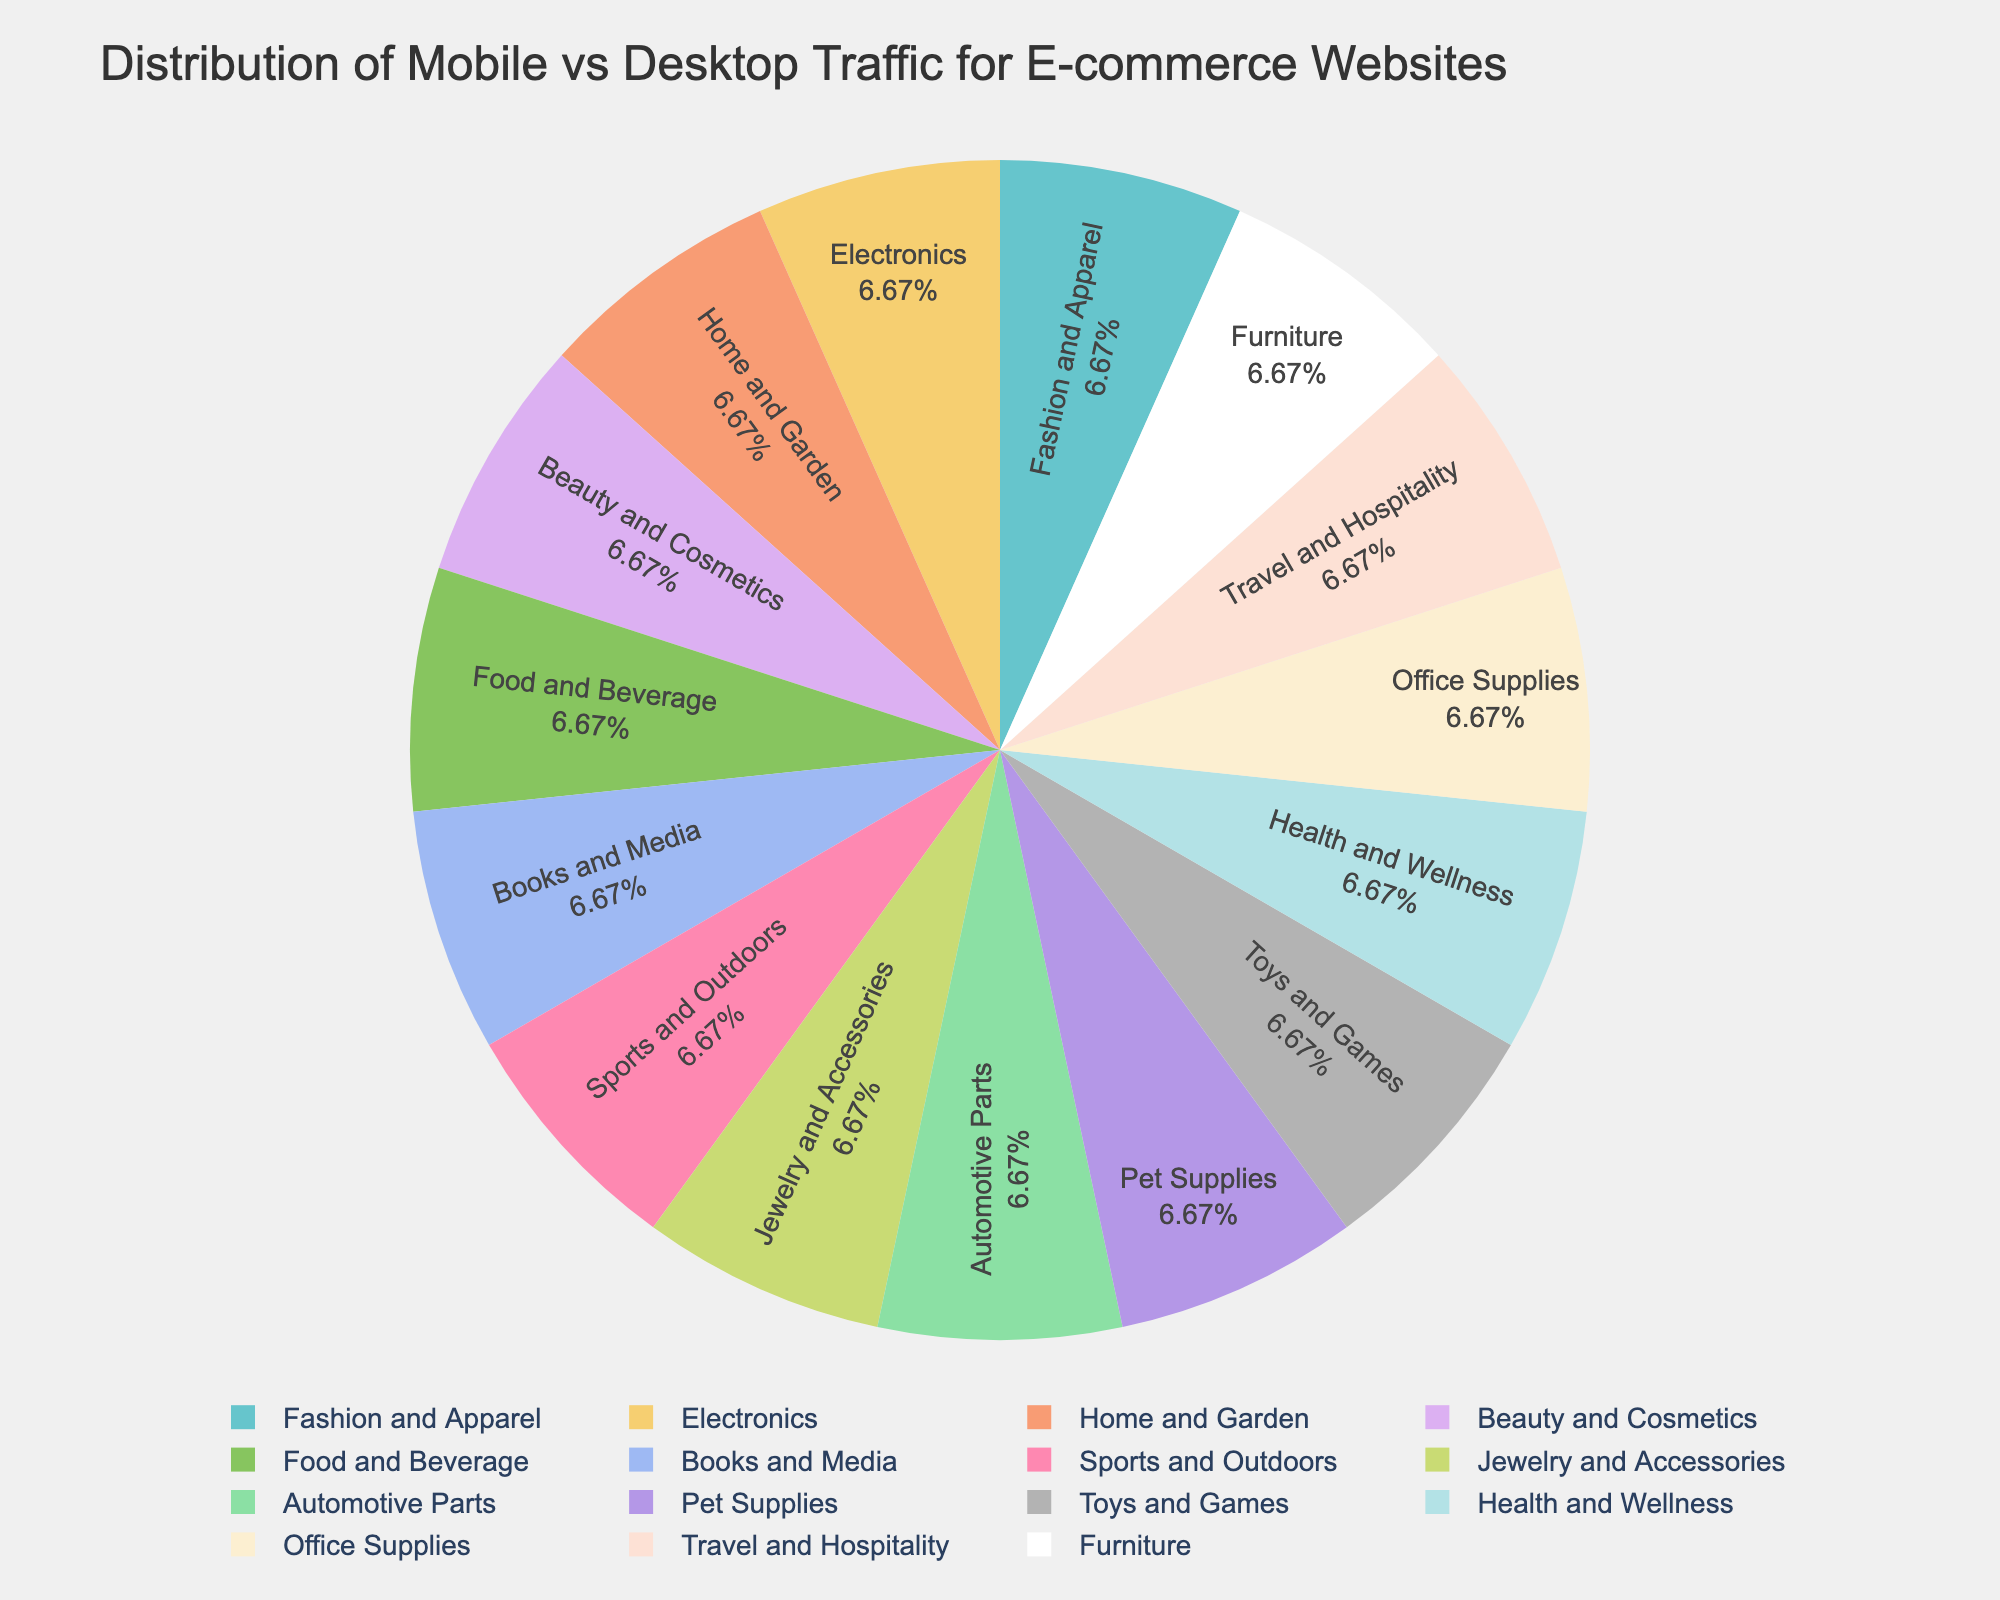Which industry has the highest mobile traffic percentage? The figure shows the percentages of mobile and desktop traffic for each industry. By comparing the mobile traffic percentages, Travel and Hospitality has the highest at 73%.
Answer: Travel and Hospitality Which industry has the lowest desktop traffic percentage? The desktop traffic percentage for each industry is presented in the figure. By identifying the lowest value, Travel and Hospitality has the lowest desktop traffic at 27%.
Answer: Travel and Hospitality What is the total traffic percentage for the Electronics industry? The total traffic percentage is the sum of mobile and desktop traffic percentages for Electronics. Mobile (52%) + Desktop (48%) = 100%.
Answer: 100% Which industries have a higher percentage of desktop traffic than mobile traffic? By comparing the mobile and desktop traffic percentages for each industry, Home and Garden (55% desktop) and Office Supplies (62% desktop) have higher desktop traffic than mobile traffic.
Answer: Home and Garden, Office Supplies What is the difference in desktop traffic percentage between the Office Supplies and Fashion and Apparel industries? The difference is calculated by subtracting the desktop traffic percentage of Fashion and Apparel (32%) from that of Office Supplies (62%). 62% - 32% = 30%.
Answer: 30% Which industry has the closest balance between mobile and desktop traffic percentages? The closest balance is where the percentages of mobile and desktop traffic are closest to each other. Furniture has 49% mobile and 51% desktop, which is very balanced.
Answer: Furniture What is the average mobile traffic percentage across all industries? Calculate the sum of mobile traffic percentages across all industries and divide by the number of industries (68+52+45+71+62+58+64+69+41+57+66+60+38+73+49)/15 = 57.87%.
Answer: 57.87% Which industry has the largest disparity between mobile and desktop traffic percentages? The largest disparity is found by identifying the industry with the largest difference between mobile and desktop percentages. Automotive Parts has a disparity of 59% - 41% = 18%.
Answer: Automotive Parts What is the combined total traffic percentage for the Fashion and Apparel and Jewelry and Accessories industries? Sum the total traffic percentages for Fashion and Apparel (100%) and Jewelry and Accessories (100%). Thus, 100% + 100% = 200%.
Answer: 200% Which industries have more than 40% desktop traffic? Identify industries with a desktop traffic percentage greater than 40%. The industries are Electronics (48%), Home and Garden (55%), Books and Media (42%), Automotive Parts (59%), Pet Supplies (43%), Office Supplies (62%), and Furniture (51%).
Answer: Electronics, Home and Garden, Books and Media, Automotive Parts, Pet Supplies, Office Supplies, Furniture 